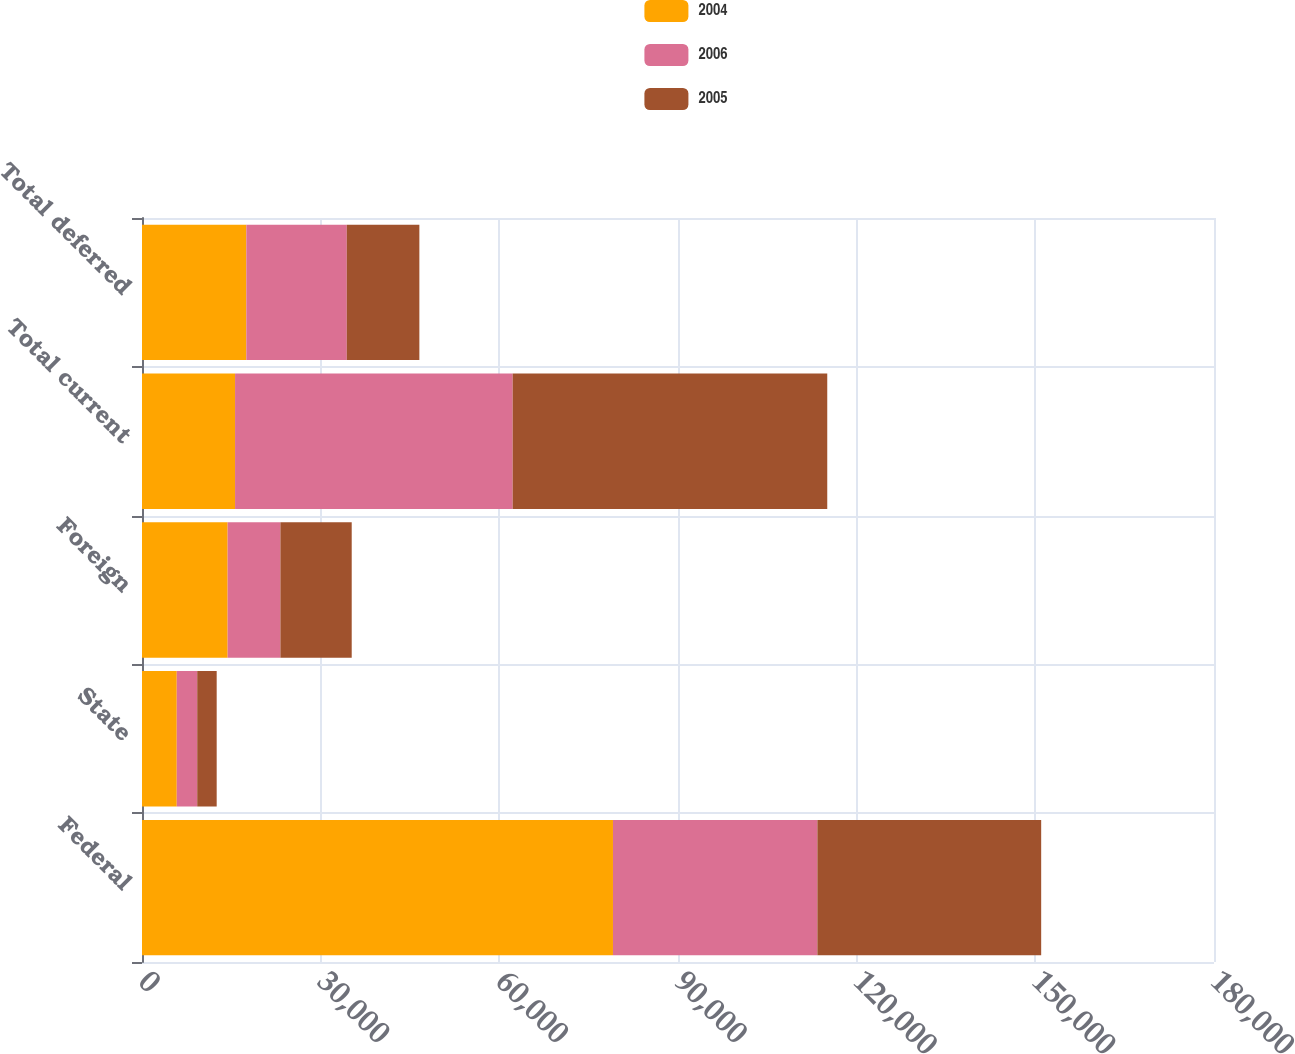Convert chart to OTSL. <chart><loc_0><loc_0><loc_500><loc_500><stacked_bar_chart><ecel><fcel>Federal<fcel>State<fcel>Foreign<fcel>Total current<fcel>Total deferred<nl><fcel>2004<fcel>79082<fcel>5837<fcel>14381<fcel>15625<fcel>17516<nl><fcel>2006<fcel>34320<fcel>3436<fcel>8858<fcel>46614<fcel>16869<nl><fcel>2005<fcel>37580<fcel>3268<fcel>11974<fcel>52822<fcel>12188<nl></chart> 